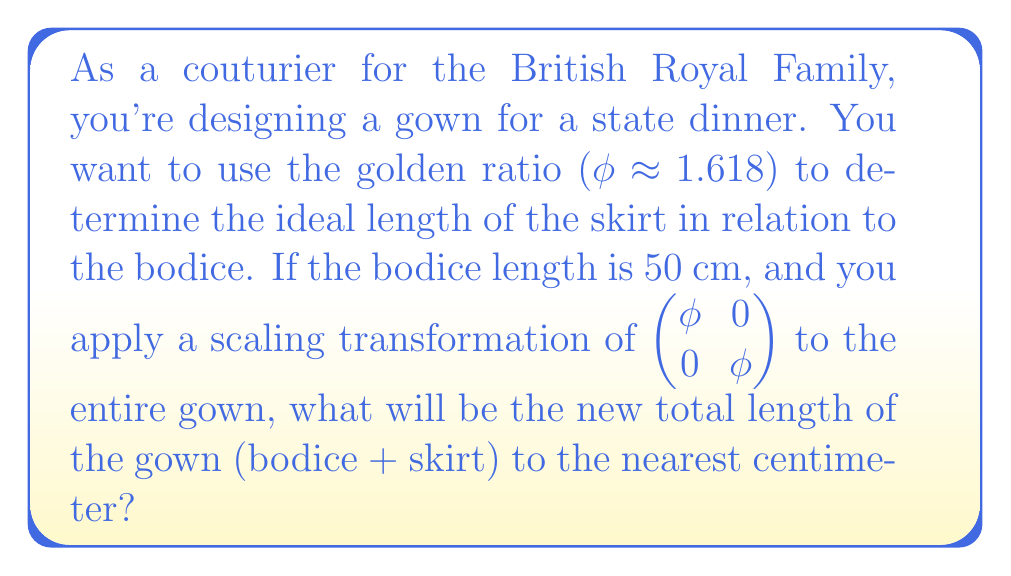Can you answer this question? Let's approach this step-by-step:

1) First, we need to determine the initial skirt length using the golden ratio. If the bodice is 50 cm, then:

   $\frac{\text{skirt}}{\text{bodice}} = \phi$

   $\text{skirt} = 50 \cdot \phi \approx 50 \cdot 1.618 = 80.9$ cm

2) The initial total length of the gown is:

   $50 + 80.9 = 130.9$ cm

3) Now, we apply the scaling transformation. The transformation matrix 
   $\begin{pmatrix} \phi & 0 \\ 0 & \phi \end{pmatrix}$ 
   scales both dimensions by $\phi$.

4) After transformation, the new total length will be:

   $130.9 \cdot \phi \approx 130.9 \cdot 1.618 = 211.7962$ cm

5) Rounding to the nearest centimeter:

   $211.7962 \approx 212$ cm
Answer: 212 cm 